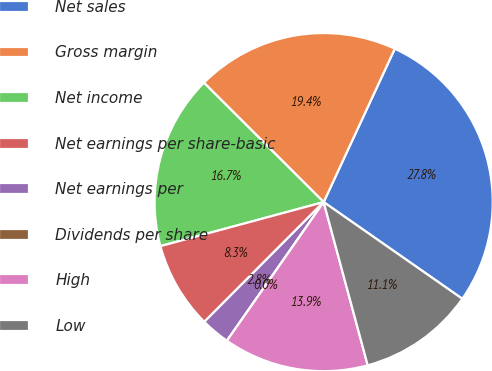Convert chart to OTSL. <chart><loc_0><loc_0><loc_500><loc_500><pie_chart><fcel>Net sales<fcel>Gross margin<fcel>Net income<fcel>Net earnings per share-basic<fcel>Net earnings per<fcel>Dividends per share<fcel>High<fcel>Low<nl><fcel>27.78%<fcel>19.44%<fcel>16.67%<fcel>8.33%<fcel>2.78%<fcel>0.0%<fcel>13.89%<fcel>11.11%<nl></chart> 